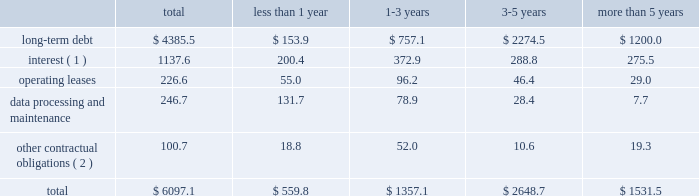Contractual obligations fis 2019 long-term contractual obligations generally include its long-term debt , interest on long-term debt , lease payments on certain of its property and equipment and payments for data processing and maintenance .
For more descriptive information regarding the company's long-term debt , see note 13 in the notes to consolidated financial statements .
The table summarizes fis 2019 significant contractual obligations and commitments as of december 31 , 2012 ( in millions ) : less than 1-3 3-5 more than total 1 year years years 5 years .
( 1 ) these calculations assume that : ( a ) applicable margins remain constant ; ( b ) all variable rate debt is priced at the one-month libor rate in effect as of december 31 , 2012 ; ( c ) no new hedging transactions are effected ; ( d ) only mandatory debt repayments are made ; and ( e ) no refinancing occurs at debt maturity .
( 2 ) amount includes the payment for labor claims related to fis' former item processing and remittance operations in brazil ( see note 3 to the consolidated financial statements ) and amounts due to the brazilian venture partner .
Fis believes that its existing cash balances , cash flows from operations and borrowing programs will provide adequate sources of liquidity and capital resources to meet fis 2019 expected short-term liquidity needs and its long-term needs for the operations of its business , expected capital spending for the next 12 months and the foreseeable future and the satisfaction of these obligations and commitments .
Off-balance sheet arrangements fis does not have any off-balance sheet arrangements .
Item 7a .
Quantitative and qualitative disclosure about market risks market risk we are exposed to market risks primarily from changes in interest rates and foreign currency exchange rates .
We use certain derivative financial instruments , including interest rate swaps and foreign currency forward exchange contracts , to manage interest rate and foreign currency risk .
We do not use derivatives for trading purposes , to generate income or to engage in speculative activity .
Interest rate risk in addition to existing cash balances and cash provided by operating activities , we use fixed rate and variable rate debt to finance our operations .
We are exposed to interest rate risk on these debt obligations and related interest rate swaps .
The notes ( as defined in note 13 to the consolidated financial statements ) represent substantially all of our fixed-rate long-term debt obligations .
The carrying value of the notes was $ 1950.0 million as of december 31 , 2012 .
The fair value of the notes was approximately $ 2138.2 million as of december 31 , 2012 .
The potential reduction in fair value of the notes from a hypothetical 10 percent increase in market interest rates would not be material to the overall fair value of the debt .
Our floating rate long-term debt obligations principally relate to borrowings under the fis credit agreement ( as also defined in note 13 to the consolidated financial statements ) .
An increase of 100 basis points in the libor rate would increase our annual debt service under the fis credit agreement , after we include the impact of our interest rate swaps , by $ 9.3 million ( based on principal amounts outstanding as of december 31 , 2012 ) .
We performed the foregoing sensitivity analysis based on the principal amount of our floating rate debt as of december 31 , 2012 , less the principal amount of such debt that was then subject to an interest rate swap converting such debt into fixed rate debt .
This sensitivity analysis is based solely on .
What portion of the long-term debt is included in the current liabilities section of the balance sheet as of december 312012? 
Computations: (153.9 / 4385.5)
Answer: 0.03509. Contractual obligations fis 2019 long-term contractual obligations generally include its long-term debt , interest on long-term debt , lease payments on certain of its property and equipment and payments for data processing and maintenance .
For more descriptive information regarding the company's long-term debt , see note 13 in the notes to consolidated financial statements .
The table summarizes fis 2019 significant contractual obligations and commitments as of december 31 , 2012 ( in millions ) : less than 1-3 3-5 more than total 1 year years years 5 years .
( 1 ) these calculations assume that : ( a ) applicable margins remain constant ; ( b ) all variable rate debt is priced at the one-month libor rate in effect as of december 31 , 2012 ; ( c ) no new hedging transactions are effected ; ( d ) only mandatory debt repayments are made ; and ( e ) no refinancing occurs at debt maturity .
( 2 ) amount includes the payment for labor claims related to fis' former item processing and remittance operations in brazil ( see note 3 to the consolidated financial statements ) and amounts due to the brazilian venture partner .
Fis believes that its existing cash balances , cash flows from operations and borrowing programs will provide adequate sources of liquidity and capital resources to meet fis 2019 expected short-term liquidity needs and its long-term needs for the operations of its business , expected capital spending for the next 12 months and the foreseeable future and the satisfaction of these obligations and commitments .
Off-balance sheet arrangements fis does not have any off-balance sheet arrangements .
Item 7a .
Quantitative and qualitative disclosure about market risks market risk we are exposed to market risks primarily from changes in interest rates and foreign currency exchange rates .
We use certain derivative financial instruments , including interest rate swaps and foreign currency forward exchange contracts , to manage interest rate and foreign currency risk .
We do not use derivatives for trading purposes , to generate income or to engage in speculative activity .
Interest rate risk in addition to existing cash balances and cash provided by operating activities , we use fixed rate and variable rate debt to finance our operations .
We are exposed to interest rate risk on these debt obligations and related interest rate swaps .
The notes ( as defined in note 13 to the consolidated financial statements ) represent substantially all of our fixed-rate long-term debt obligations .
The carrying value of the notes was $ 1950.0 million as of december 31 , 2012 .
The fair value of the notes was approximately $ 2138.2 million as of december 31 , 2012 .
The potential reduction in fair value of the notes from a hypothetical 10 percent increase in market interest rates would not be material to the overall fair value of the debt .
Our floating rate long-term debt obligations principally relate to borrowings under the fis credit agreement ( as also defined in note 13 to the consolidated financial statements ) .
An increase of 100 basis points in the libor rate would increase our annual debt service under the fis credit agreement , after we include the impact of our interest rate swaps , by $ 9.3 million ( based on principal amounts outstanding as of december 31 , 2012 ) .
We performed the foregoing sensitivity analysis based on the principal amount of our floating rate debt as of december 31 , 2012 , less the principal amount of such debt that was then subject to an interest rate swap converting such debt into fixed rate debt .
This sensitivity analysis is based solely on .
What percent of total contractual obligations and commitments as of december 31 , 2012 are data processing and maintenance? 
Computations: (246.7 / 6097.1)
Answer: 0.04046. 